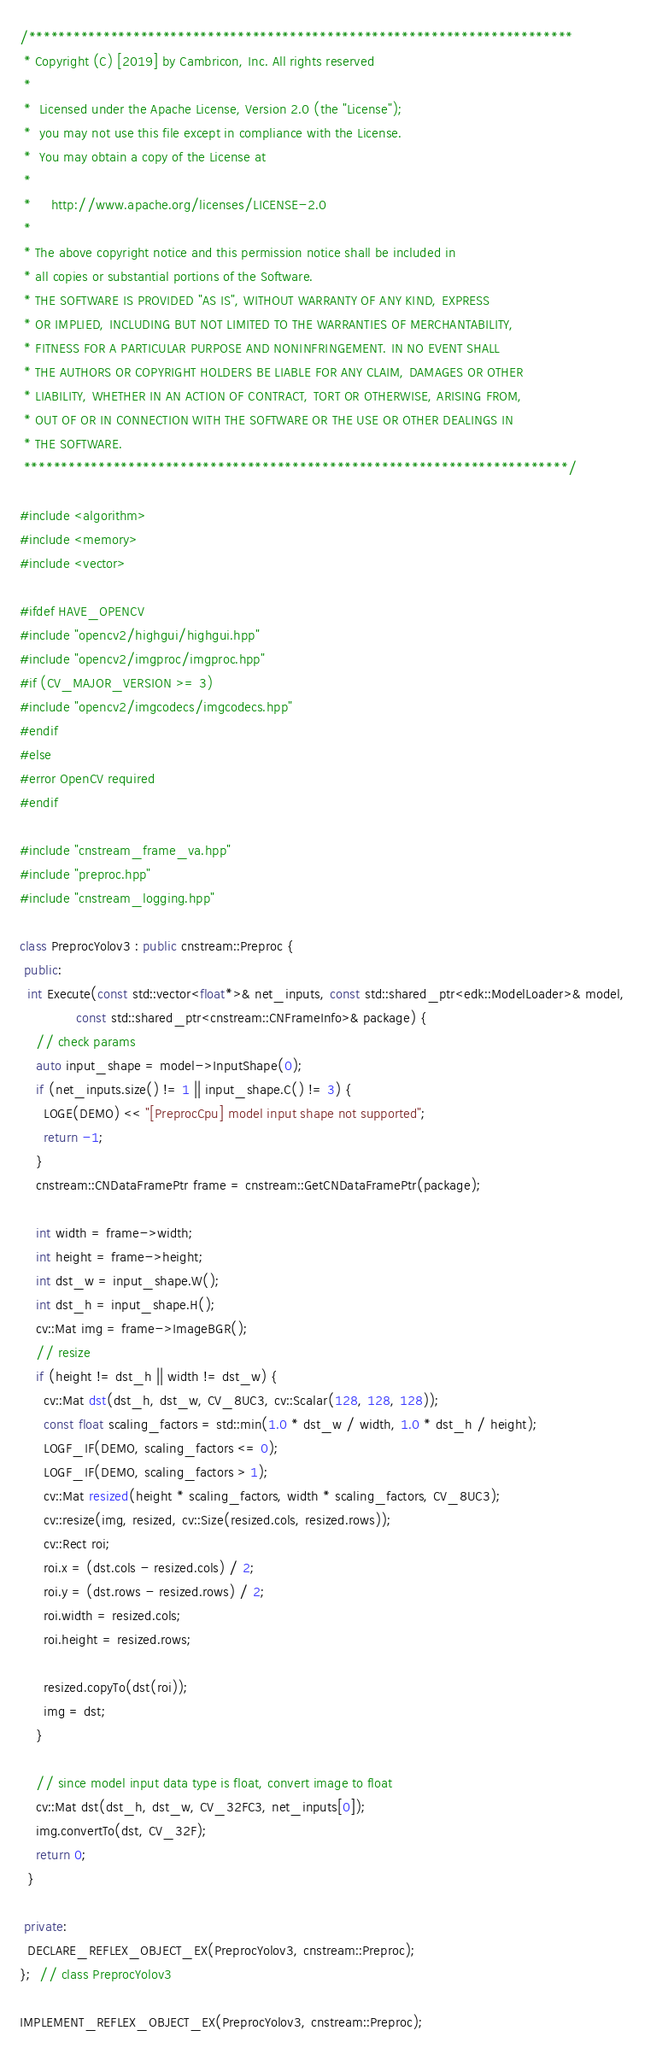<code> <loc_0><loc_0><loc_500><loc_500><_C++_>/*************************************************************************
 * Copyright (C) [2019] by Cambricon, Inc. All rights reserved
 *
 *  Licensed under the Apache License, Version 2.0 (the "License");
 *  you may not use this file except in compliance with the License.
 *  You may obtain a copy of the License at
 *
 *     http://www.apache.org/licenses/LICENSE-2.0
 *
 * The above copyright notice and this permission notice shall be included in
 * all copies or substantial portions of the Software.
 * THE SOFTWARE IS PROVIDED "AS IS", WITHOUT WARRANTY OF ANY KIND, EXPRESS
 * OR IMPLIED, INCLUDING BUT NOT LIMITED TO THE WARRANTIES OF MERCHANTABILITY,
 * FITNESS FOR A PARTICULAR PURPOSE AND NONINFRINGEMENT. IN NO EVENT SHALL
 * THE AUTHORS OR COPYRIGHT HOLDERS BE LIABLE FOR ANY CLAIM, DAMAGES OR OTHER
 * LIABILITY, WHETHER IN AN ACTION OF CONTRACT, TORT OR OTHERWISE, ARISING FROM,
 * OUT OF OR IN CONNECTION WITH THE SOFTWARE OR THE USE OR OTHER DEALINGS IN
 * THE SOFTWARE.
 *************************************************************************/

#include <algorithm>
#include <memory>
#include <vector>

#ifdef HAVE_OPENCV
#include "opencv2/highgui/highgui.hpp"
#include "opencv2/imgproc/imgproc.hpp"
#if (CV_MAJOR_VERSION >= 3)
#include "opencv2/imgcodecs/imgcodecs.hpp"
#endif
#else
#error OpenCV required
#endif

#include "cnstream_frame_va.hpp"
#include "preproc.hpp"
#include "cnstream_logging.hpp"

class PreprocYolov3 : public cnstream::Preproc {
 public:
  int Execute(const std::vector<float*>& net_inputs, const std::shared_ptr<edk::ModelLoader>& model,
              const std::shared_ptr<cnstream::CNFrameInfo>& package) {
    // check params
    auto input_shape = model->InputShape(0);
    if (net_inputs.size() != 1 || input_shape.C() != 3) {
      LOGE(DEMO) << "[PreprocCpu] model input shape not supported";
      return -1;
    }
    cnstream::CNDataFramePtr frame = cnstream::GetCNDataFramePtr(package);

    int width = frame->width;
    int height = frame->height;
    int dst_w = input_shape.W();
    int dst_h = input_shape.H();
    cv::Mat img = frame->ImageBGR();
    // resize
    if (height != dst_h || width != dst_w) {
      cv::Mat dst(dst_h, dst_w, CV_8UC3, cv::Scalar(128, 128, 128));
      const float scaling_factors = std::min(1.0 * dst_w / width, 1.0 * dst_h / height);
      LOGF_IF(DEMO, scaling_factors <= 0);
      LOGF_IF(DEMO, scaling_factors > 1);
      cv::Mat resized(height * scaling_factors, width * scaling_factors, CV_8UC3);
      cv::resize(img, resized, cv::Size(resized.cols, resized.rows));
      cv::Rect roi;
      roi.x = (dst.cols - resized.cols) / 2;
      roi.y = (dst.rows - resized.rows) / 2;
      roi.width = resized.cols;
      roi.height = resized.rows;

      resized.copyTo(dst(roi));
      img = dst;
    }

    // since model input data type is float, convert image to float
    cv::Mat dst(dst_h, dst_w, CV_32FC3, net_inputs[0]);
    img.convertTo(dst, CV_32F);
    return 0;
  }

 private:
  DECLARE_REFLEX_OBJECT_EX(PreprocYolov3, cnstream::Preproc);
};  // class PreprocYolov3

IMPLEMENT_REFLEX_OBJECT_EX(PreprocYolov3, cnstream::Preproc);
</code> 